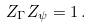Convert formula to latex. <formula><loc_0><loc_0><loc_500><loc_500>Z _ { \Gamma } Z _ { \psi } = 1 \, .</formula> 